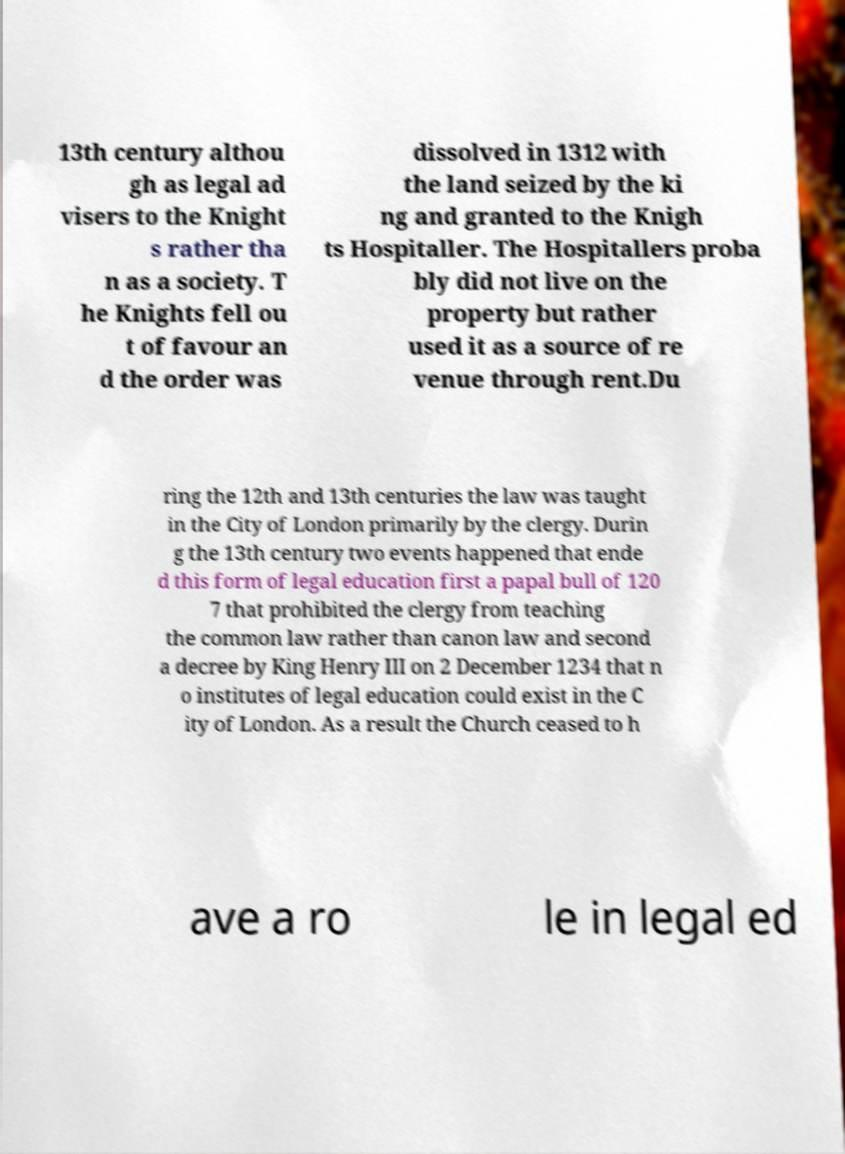I need the written content from this picture converted into text. Can you do that? 13th century althou gh as legal ad visers to the Knight s rather tha n as a society. T he Knights fell ou t of favour an d the order was dissolved in 1312 with the land seized by the ki ng and granted to the Knigh ts Hospitaller. The Hospitallers proba bly did not live on the property but rather used it as a source of re venue through rent.Du ring the 12th and 13th centuries the law was taught in the City of London primarily by the clergy. Durin g the 13th century two events happened that ende d this form of legal education first a papal bull of 120 7 that prohibited the clergy from teaching the common law rather than canon law and second a decree by King Henry III on 2 December 1234 that n o institutes of legal education could exist in the C ity of London. As a result the Church ceased to h ave a ro le in legal ed 